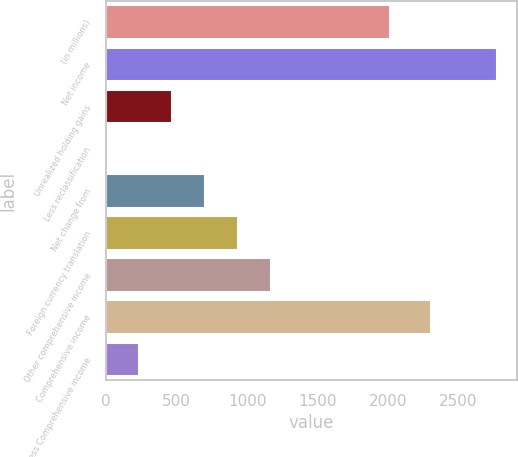Convert chart. <chart><loc_0><loc_0><loc_500><loc_500><bar_chart><fcel>(in millions)<fcel>Net income<fcel>Unrealized holding gains<fcel>Less reclassification<fcel>Net change from<fcel>Foreign currency translation<fcel>Other comprehensive income<fcel>Comprehensive income<fcel>Less Comprehensive income<nl><fcel>2011<fcel>2773.6<fcel>468.6<fcel>1<fcel>702.4<fcel>936.2<fcel>1170<fcel>2306<fcel>234.8<nl></chart> 